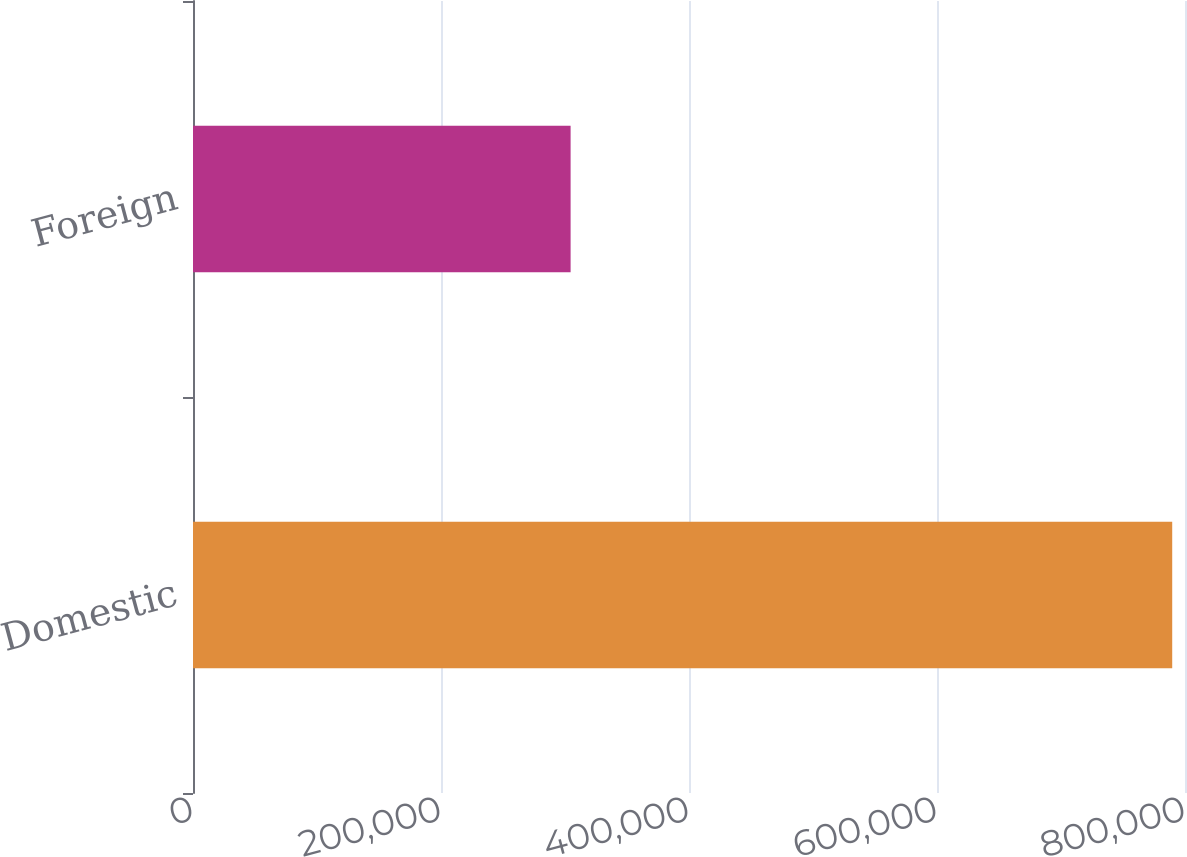Convert chart to OTSL. <chart><loc_0><loc_0><loc_500><loc_500><bar_chart><fcel>Domestic<fcel>Foreign<nl><fcel>789689<fcel>304518<nl></chart> 